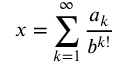Convert formula to latex. <formula><loc_0><loc_0><loc_500><loc_500>x = \sum _ { k = 1 } ^ { \infty } { \frac { a _ { k } } { b ^ { k ! } } }</formula> 